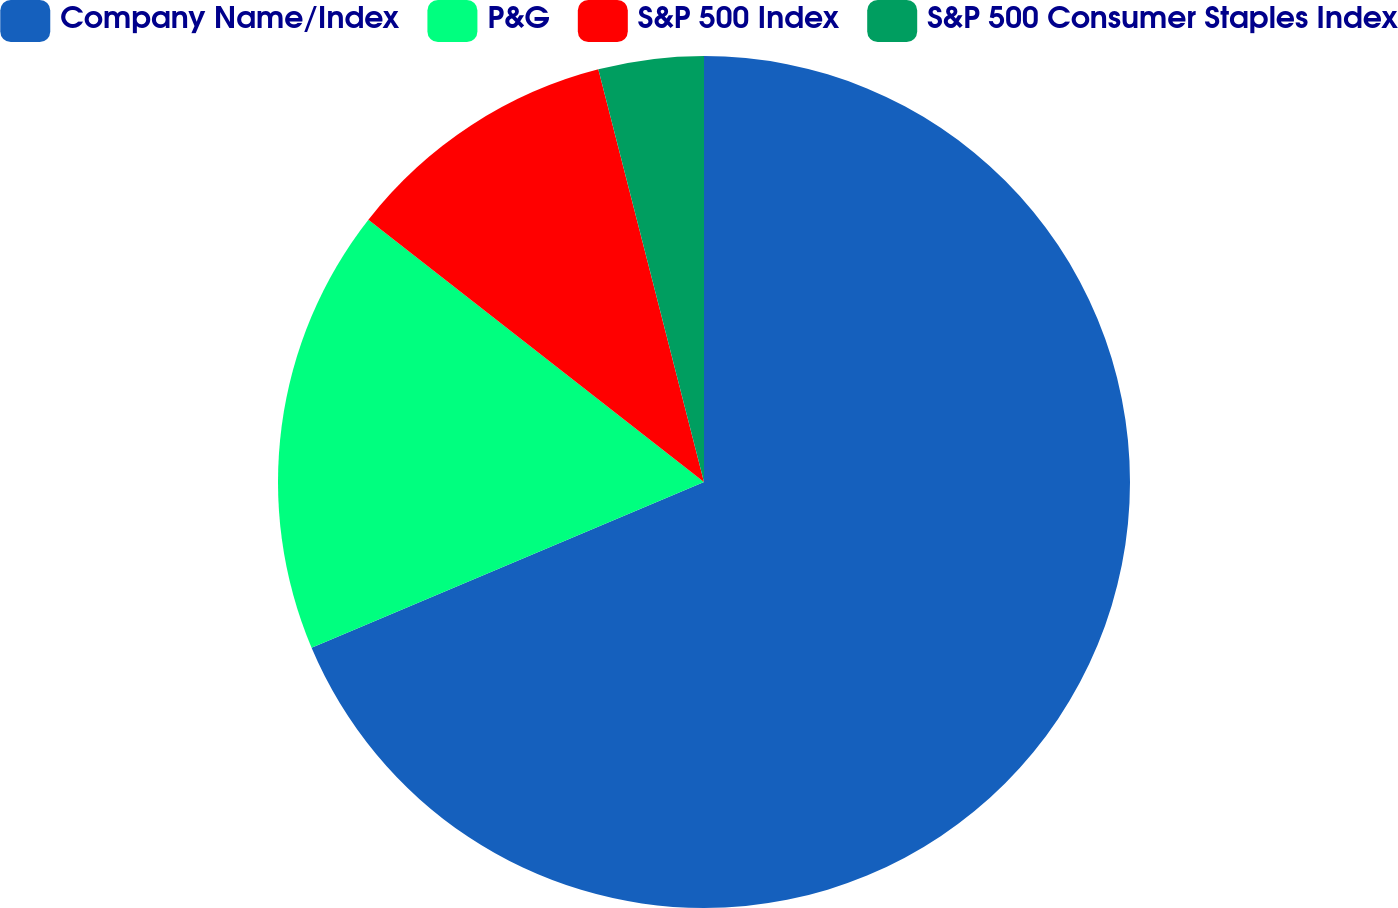<chart> <loc_0><loc_0><loc_500><loc_500><pie_chart><fcel>Company Name/Index<fcel>P&G<fcel>S&P 500 Index<fcel>S&P 500 Consumer Staples Index<nl><fcel>68.64%<fcel>16.92%<fcel>10.45%<fcel>3.99%<nl></chart> 